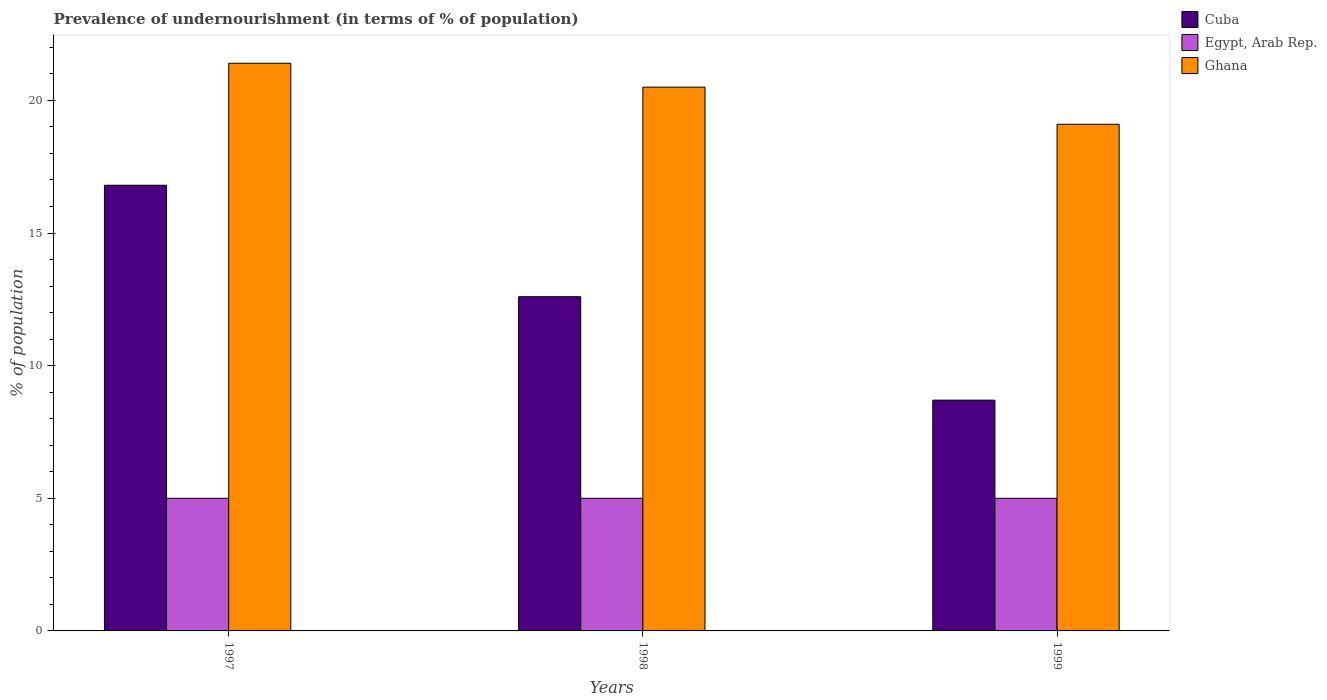How many groups of bars are there?
Provide a short and direct response. 3. Are the number of bars per tick equal to the number of legend labels?
Offer a terse response. Yes. How many bars are there on the 3rd tick from the left?
Ensure brevity in your answer.  3. How many bars are there on the 1st tick from the right?
Your answer should be very brief. 3. In how many cases, is the number of bars for a given year not equal to the number of legend labels?
Your answer should be compact. 0. In which year was the percentage of undernourished population in Ghana maximum?
Ensure brevity in your answer.  1997. What is the difference between the percentage of undernourished population in Ghana in 1997 and that in 1999?
Keep it short and to the point. 2.3. What is the difference between the percentage of undernourished population in Egypt, Arab Rep. in 1997 and the percentage of undernourished population in Cuba in 1999?
Give a very brief answer. -3.7. What is the average percentage of undernourished population in Ghana per year?
Give a very brief answer. 20.33. In the year 1997, what is the difference between the percentage of undernourished population in Egypt, Arab Rep. and percentage of undernourished population in Ghana?
Keep it short and to the point. -16.4. In how many years, is the percentage of undernourished population in Ghana greater than 10 %?
Make the answer very short. 3. What is the ratio of the percentage of undernourished population in Ghana in 1997 to that in 1998?
Your answer should be very brief. 1.04. Is the percentage of undernourished population in Ghana in 1997 less than that in 1999?
Keep it short and to the point. No. What is the difference between the highest and the lowest percentage of undernourished population in Ghana?
Offer a very short reply. 2.3. What does the 2nd bar from the left in 1999 represents?
Offer a very short reply. Egypt, Arab Rep. What does the 3rd bar from the right in 1997 represents?
Your answer should be compact. Cuba. Is it the case that in every year, the sum of the percentage of undernourished population in Cuba and percentage of undernourished population in Egypt, Arab Rep. is greater than the percentage of undernourished population in Ghana?
Your answer should be compact. No. How many years are there in the graph?
Offer a very short reply. 3. Are the values on the major ticks of Y-axis written in scientific E-notation?
Ensure brevity in your answer.  No. Does the graph contain any zero values?
Your answer should be compact. No. Does the graph contain grids?
Provide a short and direct response. No. Where does the legend appear in the graph?
Provide a short and direct response. Top right. How many legend labels are there?
Make the answer very short. 3. How are the legend labels stacked?
Provide a short and direct response. Vertical. What is the title of the graph?
Keep it short and to the point. Prevalence of undernourishment (in terms of % of population). What is the label or title of the Y-axis?
Offer a terse response. % of population. What is the % of population of Egypt, Arab Rep. in 1997?
Make the answer very short. 5. What is the % of population in Ghana in 1997?
Offer a terse response. 21.4. What is the % of population in Egypt, Arab Rep. in 1998?
Your response must be concise. 5. What is the % of population of Ghana in 1998?
Make the answer very short. 20.5. What is the % of population of Cuba in 1999?
Offer a terse response. 8.7. Across all years, what is the maximum % of population of Cuba?
Your answer should be very brief. 16.8. Across all years, what is the maximum % of population in Egypt, Arab Rep.?
Offer a terse response. 5. Across all years, what is the maximum % of population of Ghana?
Your answer should be very brief. 21.4. Across all years, what is the minimum % of population of Ghana?
Your response must be concise. 19.1. What is the total % of population in Cuba in the graph?
Your answer should be very brief. 38.1. What is the total % of population in Egypt, Arab Rep. in the graph?
Give a very brief answer. 15. What is the total % of population in Ghana in the graph?
Offer a very short reply. 61. What is the difference between the % of population in Cuba in 1997 and that in 1998?
Offer a very short reply. 4.2. What is the difference between the % of population of Cuba in 1997 and that in 1999?
Make the answer very short. 8.1. What is the difference between the % of population of Egypt, Arab Rep. in 1997 and that in 1999?
Your answer should be compact. 0. What is the difference between the % of population in Egypt, Arab Rep. in 1998 and that in 1999?
Give a very brief answer. 0. What is the difference between the % of population in Cuba in 1997 and the % of population in Ghana in 1998?
Your answer should be very brief. -3.7. What is the difference between the % of population in Egypt, Arab Rep. in 1997 and the % of population in Ghana in 1998?
Your answer should be compact. -15.5. What is the difference between the % of population in Cuba in 1997 and the % of population in Egypt, Arab Rep. in 1999?
Your answer should be compact. 11.8. What is the difference between the % of population of Egypt, Arab Rep. in 1997 and the % of population of Ghana in 1999?
Provide a short and direct response. -14.1. What is the difference between the % of population in Egypt, Arab Rep. in 1998 and the % of population in Ghana in 1999?
Keep it short and to the point. -14.1. What is the average % of population in Egypt, Arab Rep. per year?
Offer a very short reply. 5. What is the average % of population of Ghana per year?
Offer a very short reply. 20.33. In the year 1997, what is the difference between the % of population in Cuba and % of population in Ghana?
Give a very brief answer. -4.6. In the year 1997, what is the difference between the % of population of Egypt, Arab Rep. and % of population of Ghana?
Make the answer very short. -16.4. In the year 1998, what is the difference between the % of population in Egypt, Arab Rep. and % of population in Ghana?
Ensure brevity in your answer.  -15.5. In the year 1999, what is the difference between the % of population in Cuba and % of population in Egypt, Arab Rep.?
Provide a short and direct response. 3.7. In the year 1999, what is the difference between the % of population in Egypt, Arab Rep. and % of population in Ghana?
Make the answer very short. -14.1. What is the ratio of the % of population of Ghana in 1997 to that in 1998?
Keep it short and to the point. 1.04. What is the ratio of the % of population of Cuba in 1997 to that in 1999?
Provide a succinct answer. 1.93. What is the ratio of the % of population of Egypt, Arab Rep. in 1997 to that in 1999?
Make the answer very short. 1. What is the ratio of the % of population of Ghana in 1997 to that in 1999?
Provide a succinct answer. 1.12. What is the ratio of the % of population of Cuba in 1998 to that in 1999?
Your response must be concise. 1.45. What is the ratio of the % of population of Egypt, Arab Rep. in 1998 to that in 1999?
Offer a terse response. 1. What is the ratio of the % of population in Ghana in 1998 to that in 1999?
Give a very brief answer. 1.07. What is the difference between the highest and the second highest % of population in Cuba?
Give a very brief answer. 4.2. What is the difference between the highest and the lowest % of population of Egypt, Arab Rep.?
Provide a short and direct response. 0. What is the difference between the highest and the lowest % of population of Ghana?
Provide a succinct answer. 2.3. 